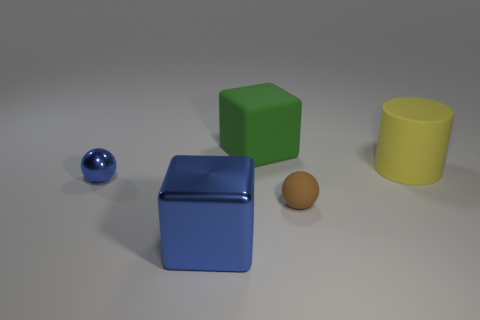Add 3 yellow metal cylinders. How many objects exist? 8 Subtract all blocks. How many objects are left? 3 Add 5 large rubber objects. How many large rubber objects are left? 7 Add 4 big shiny objects. How many big shiny objects exist? 5 Subtract 0 purple balls. How many objects are left? 5 Subtract all big cyan spheres. Subtract all green things. How many objects are left? 4 